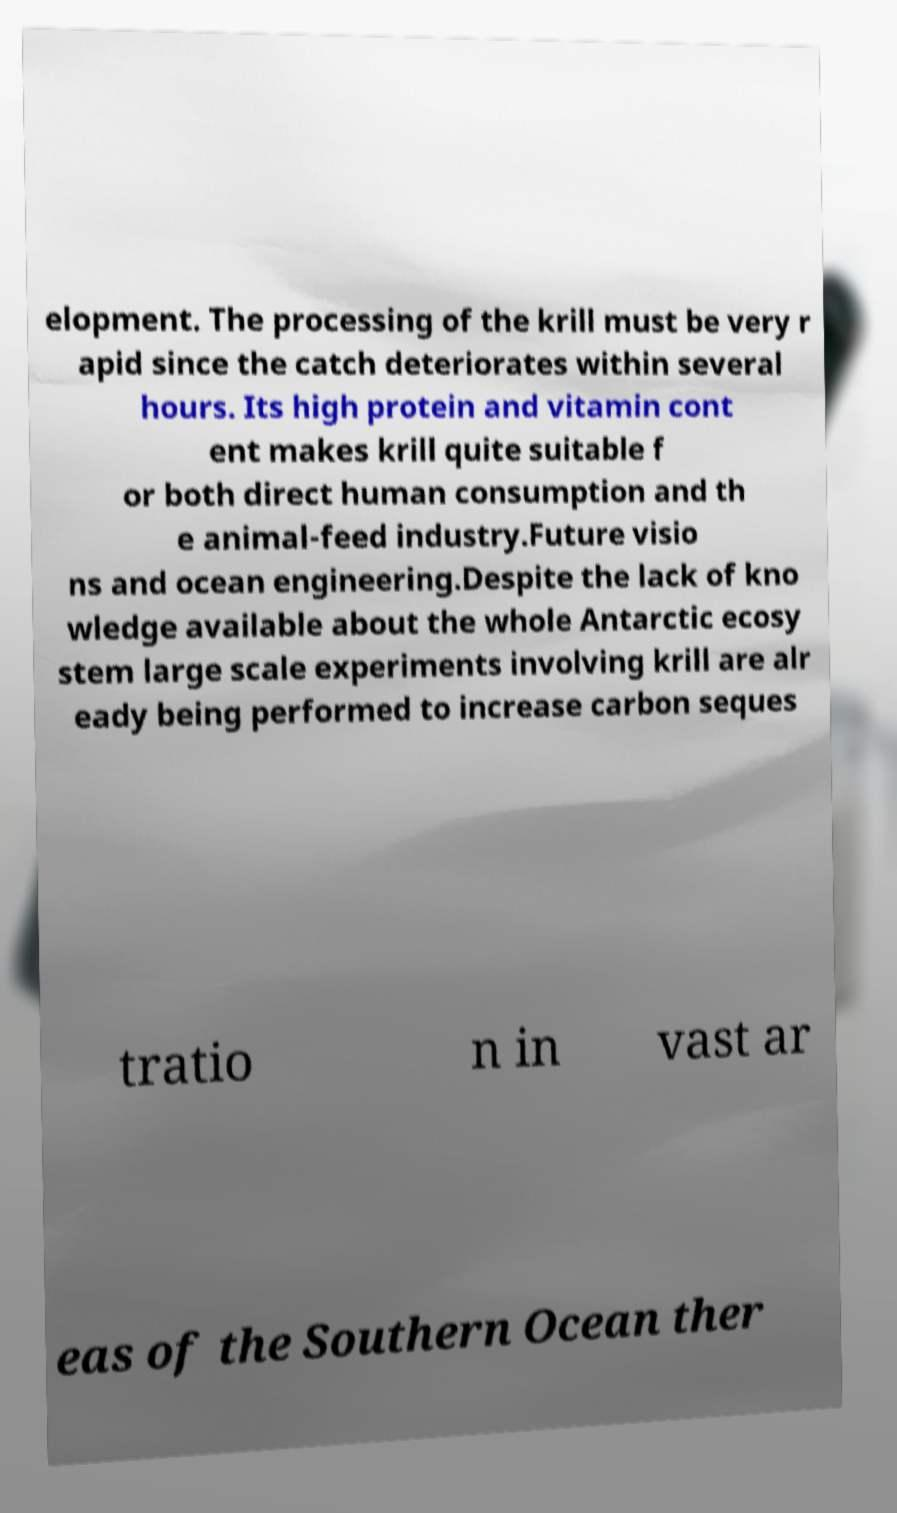Can you accurately transcribe the text from the provided image for me? elopment. The processing of the krill must be very r apid since the catch deteriorates within several hours. Its high protein and vitamin cont ent makes krill quite suitable f or both direct human consumption and th e animal-feed industry.Future visio ns and ocean engineering.Despite the lack of kno wledge available about the whole Antarctic ecosy stem large scale experiments involving krill are alr eady being performed to increase carbon seques tratio n in vast ar eas of the Southern Ocean ther 